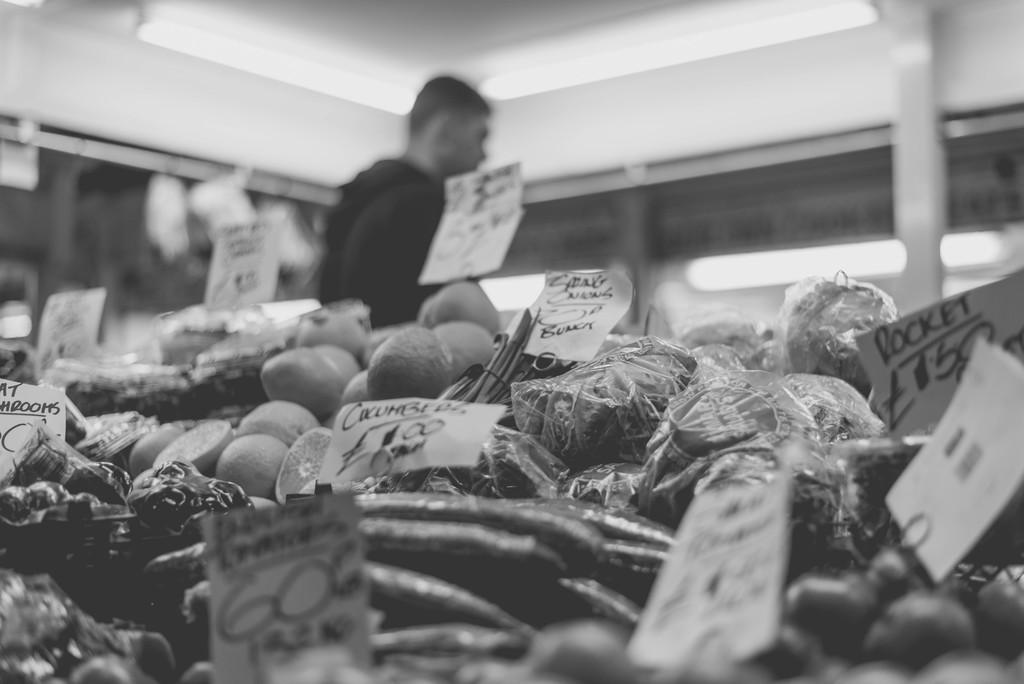What is the main subject of the image? The main subject of the image is different types of vegetables. How can you tell the price of the vegetables? The vegetables have price tags in the image. What can be seen in the background of the image? There is a wall, a person standing, and a few other objects in the background. What type of sponge is being used to clean the vegetables in the image? There is no sponge present in the image, and the vegetables are not being cleaned. Can you tell if the person in the background is approving or disapproving of the vegetables? There is no indication of the person's approval or disapproval in the image, as their facial expression or body language is not visible. 